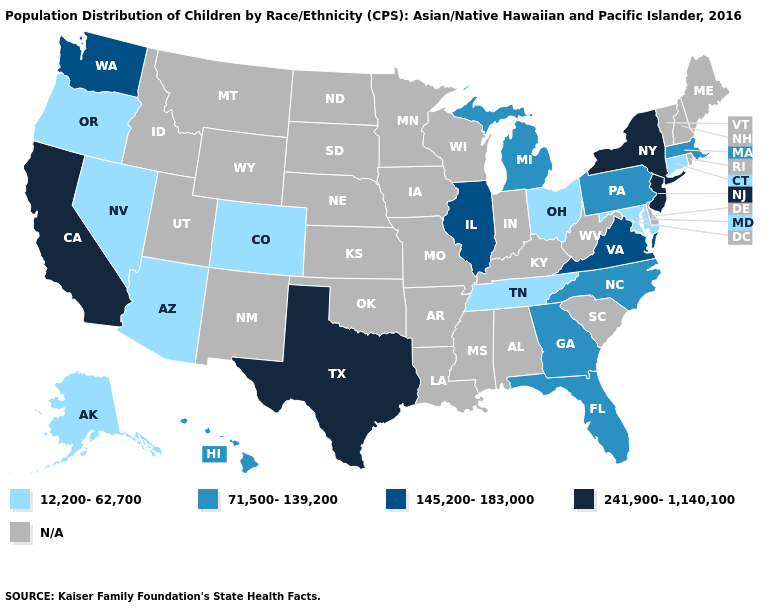Which states have the highest value in the USA?
Answer briefly. California, New Jersey, New York, Texas. What is the value of South Carolina?
Concise answer only. N/A. Among the states that border Maryland , does Pennsylvania have the lowest value?
Answer briefly. Yes. What is the value of Rhode Island?
Be succinct. N/A. How many symbols are there in the legend?
Short answer required. 5. How many symbols are there in the legend?
Keep it brief. 5. Name the states that have a value in the range 241,900-1,140,100?
Concise answer only. California, New Jersey, New York, Texas. What is the highest value in the MidWest ?
Short answer required. 145,200-183,000. Which states hav the highest value in the MidWest?
Short answer required. Illinois. Name the states that have a value in the range 241,900-1,140,100?
Concise answer only. California, New Jersey, New York, Texas. What is the value of Indiana?
Quick response, please. N/A. Is the legend a continuous bar?
Give a very brief answer. No. Which states have the lowest value in the Northeast?
Concise answer only. Connecticut. Name the states that have a value in the range 145,200-183,000?
Write a very short answer. Illinois, Virginia, Washington. 